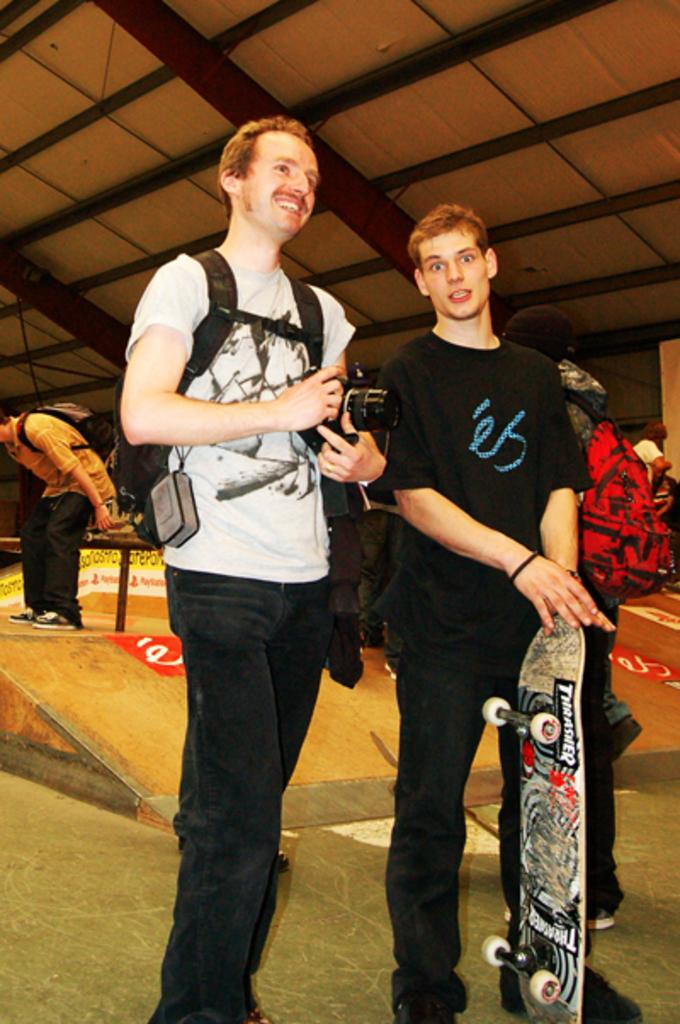What are the people in the image doing? There are people standing in the image, with one person holding a camera and another holding a skateboard. What object is the person with the camera likely using? The person with the camera is likely using it to take pictures or record a video. What can be seen in the background of the image? There is a shed visible in the background of the image. What is the son's favorite hour of the day in the image? There is no mention of a son or a specific hour of the day in the image, so this information cannot be determined. 